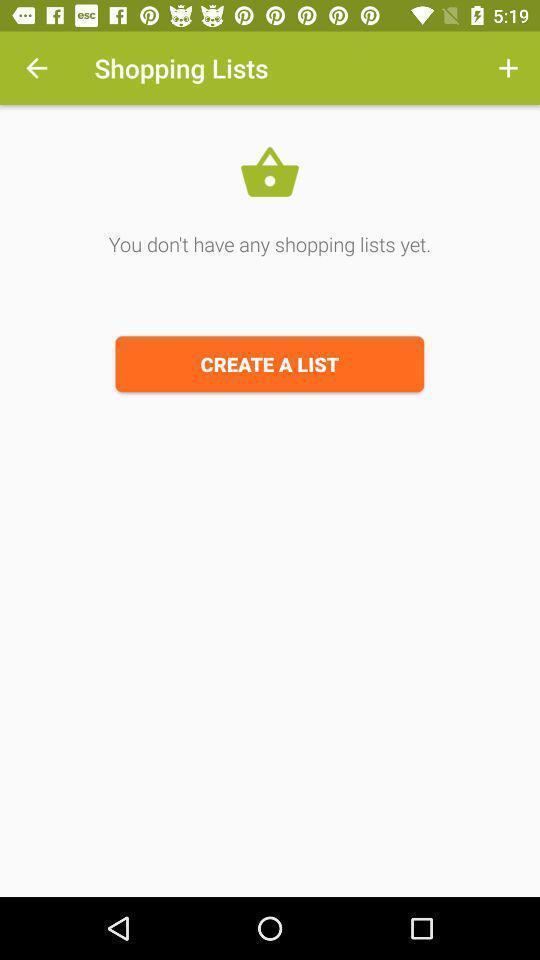Summarize the main components in this picture. Shopping app displayed create a shopping list. 